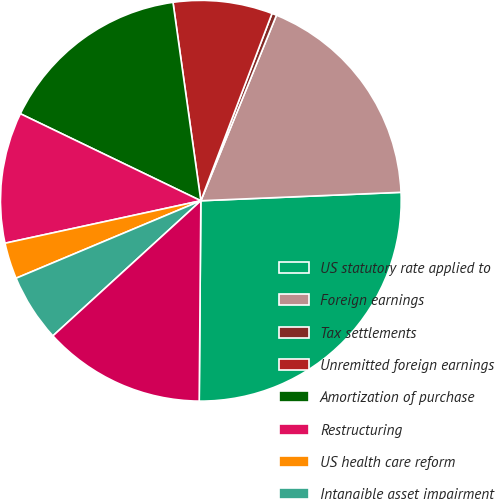<chart> <loc_0><loc_0><loc_500><loc_500><pie_chart><fcel>US statutory rate applied to<fcel>Foreign earnings<fcel>Tax settlements<fcel>Unremitted foreign earnings<fcel>Amortization of purchase<fcel>Restructuring<fcel>US health care reform<fcel>Intangible asset impairment<fcel>Other (1)<nl><fcel>25.8%<fcel>18.17%<fcel>0.38%<fcel>8.0%<fcel>15.63%<fcel>10.55%<fcel>2.92%<fcel>5.46%<fcel>13.09%<nl></chart> 